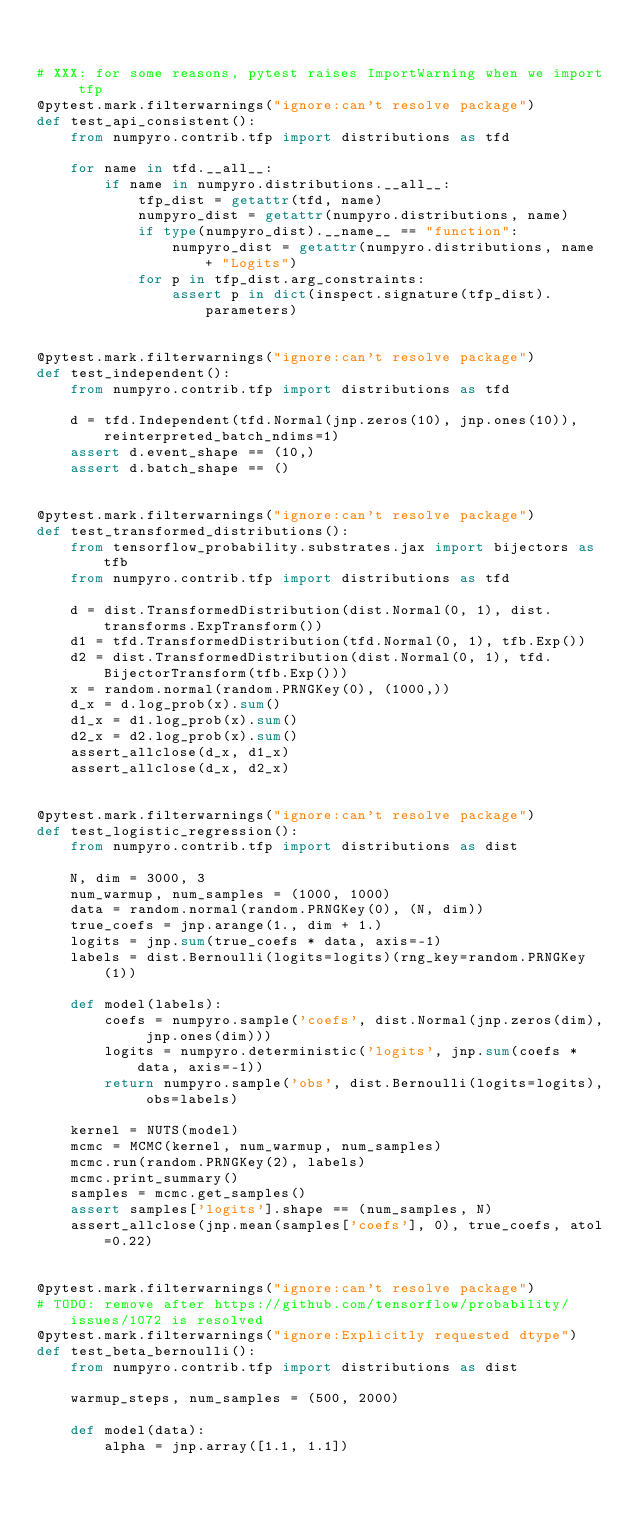Convert code to text. <code><loc_0><loc_0><loc_500><loc_500><_Python_>

# XXX: for some reasons, pytest raises ImportWarning when we import tfp
@pytest.mark.filterwarnings("ignore:can't resolve package")
def test_api_consistent():
    from numpyro.contrib.tfp import distributions as tfd

    for name in tfd.__all__:
        if name in numpyro.distributions.__all__:
            tfp_dist = getattr(tfd, name)
            numpyro_dist = getattr(numpyro.distributions, name)
            if type(numpyro_dist).__name__ == "function":
                numpyro_dist = getattr(numpyro.distributions, name + "Logits")
            for p in tfp_dist.arg_constraints:
                assert p in dict(inspect.signature(tfp_dist).parameters)


@pytest.mark.filterwarnings("ignore:can't resolve package")
def test_independent():
    from numpyro.contrib.tfp import distributions as tfd

    d = tfd.Independent(tfd.Normal(jnp.zeros(10), jnp.ones(10)), reinterpreted_batch_ndims=1)
    assert d.event_shape == (10,)
    assert d.batch_shape == ()


@pytest.mark.filterwarnings("ignore:can't resolve package")
def test_transformed_distributions():
    from tensorflow_probability.substrates.jax import bijectors as tfb
    from numpyro.contrib.tfp import distributions as tfd

    d = dist.TransformedDistribution(dist.Normal(0, 1), dist.transforms.ExpTransform())
    d1 = tfd.TransformedDistribution(tfd.Normal(0, 1), tfb.Exp())
    d2 = dist.TransformedDistribution(dist.Normal(0, 1), tfd.BijectorTransform(tfb.Exp()))
    x = random.normal(random.PRNGKey(0), (1000,))
    d_x = d.log_prob(x).sum()
    d1_x = d1.log_prob(x).sum()
    d2_x = d2.log_prob(x).sum()
    assert_allclose(d_x, d1_x)
    assert_allclose(d_x, d2_x)


@pytest.mark.filterwarnings("ignore:can't resolve package")
def test_logistic_regression():
    from numpyro.contrib.tfp import distributions as dist

    N, dim = 3000, 3
    num_warmup, num_samples = (1000, 1000)
    data = random.normal(random.PRNGKey(0), (N, dim))
    true_coefs = jnp.arange(1., dim + 1.)
    logits = jnp.sum(true_coefs * data, axis=-1)
    labels = dist.Bernoulli(logits=logits)(rng_key=random.PRNGKey(1))

    def model(labels):
        coefs = numpyro.sample('coefs', dist.Normal(jnp.zeros(dim), jnp.ones(dim)))
        logits = numpyro.deterministic('logits', jnp.sum(coefs * data, axis=-1))
        return numpyro.sample('obs', dist.Bernoulli(logits=logits), obs=labels)

    kernel = NUTS(model)
    mcmc = MCMC(kernel, num_warmup, num_samples)
    mcmc.run(random.PRNGKey(2), labels)
    mcmc.print_summary()
    samples = mcmc.get_samples()
    assert samples['logits'].shape == (num_samples, N)
    assert_allclose(jnp.mean(samples['coefs'], 0), true_coefs, atol=0.22)


@pytest.mark.filterwarnings("ignore:can't resolve package")
# TODO: remove after https://github.com/tensorflow/probability/issues/1072 is resolved
@pytest.mark.filterwarnings("ignore:Explicitly requested dtype")
def test_beta_bernoulli():
    from numpyro.contrib.tfp import distributions as dist

    warmup_steps, num_samples = (500, 2000)

    def model(data):
        alpha = jnp.array([1.1, 1.1])</code> 